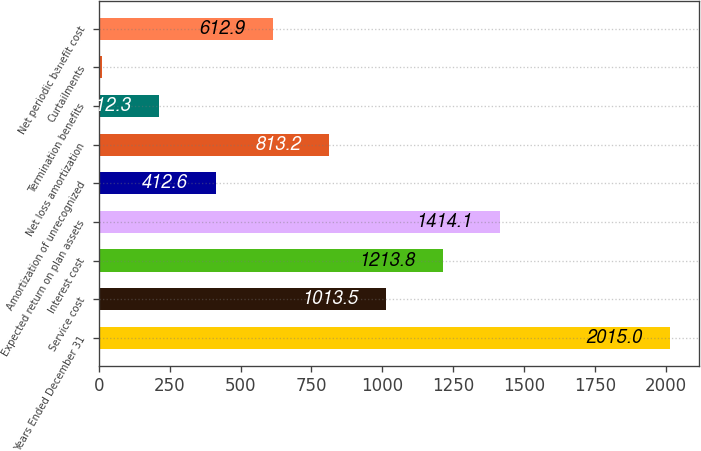<chart> <loc_0><loc_0><loc_500><loc_500><bar_chart><fcel>Years Ended December 31<fcel>Service cost<fcel>Interest cost<fcel>Expected return on plan assets<fcel>Amortization of unrecognized<fcel>Net loss amortization<fcel>Termination benefits<fcel>Curtailments<fcel>Net periodic benefit cost<nl><fcel>2015<fcel>1013.5<fcel>1213.8<fcel>1414.1<fcel>412.6<fcel>813.2<fcel>212.3<fcel>12<fcel>612.9<nl></chart> 